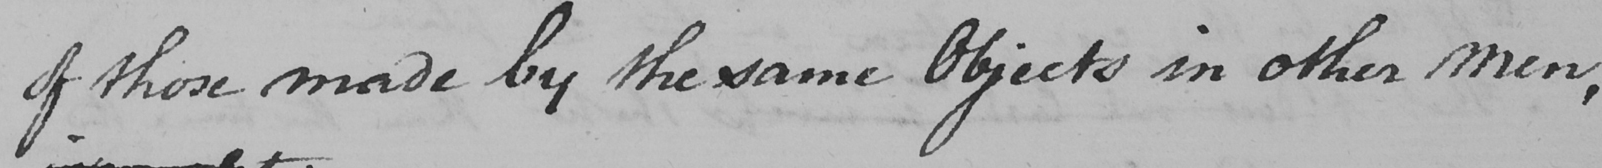What does this handwritten line say? of those made by the same Objects in other men , 